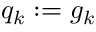Convert formula to latex. <formula><loc_0><loc_0><loc_500><loc_500>q _ { k } \colon = g _ { k }</formula> 